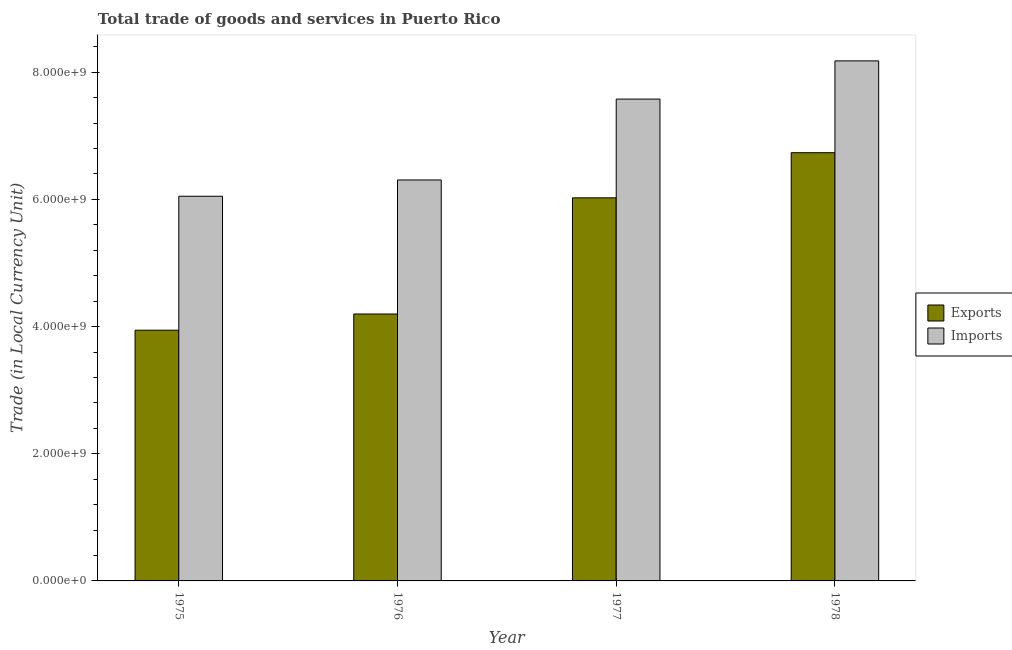How many different coloured bars are there?
Provide a succinct answer. 2. How many groups of bars are there?
Provide a succinct answer. 4. Are the number of bars per tick equal to the number of legend labels?
Keep it short and to the point. Yes. Are the number of bars on each tick of the X-axis equal?
Your answer should be very brief. Yes. How many bars are there on the 3rd tick from the left?
Ensure brevity in your answer.  2. What is the label of the 3rd group of bars from the left?
Provide a succinct answer. 1977. In how many cases, is the number of bars for a given year not equal to the number of legend labels?
Provide a succinct answer. 0. What is the imports of goods and services in 1975?
Give a very brief answer. 6.05e+09. Across all years, what is the maximum export of goods and services?
Ensure brevity in your answer.  6.74e+09. Across all years, what is the minimum imports of goods and services?
Your answer should be compact. 6.05e+09. In which year was the export of goods and services maximum?
Your answer should be very brief. 1978. In which year was the export of goods and services minimum?
Your answer should be compact. 1975. What is the total imports of goods and services in the graph?
Provide a short and direct response. 2.81e+1. What is the difference between the export of goods and services in 1977 and that in 1978?
Provide a short and direct response. -7.10e+08. What is the difference between the export of goods and services in 1975 and the imports of goods and services in 1976?
Offer a very short reply. -2.55e+08. What is the average imports of goods and services per year?
Make the answer very short. 7.03e+09. In how many years, is the export of goods and services greater than 800000000 LCU?
Provide a short and direct response. 4. What is the ratio of the export of goods and services in 1977 to that in 1978?
Provide a succinct answer. 0.89. What is the difference between the highest and the second highest imports of goods and services?
Your answer should be compact. 6.01e+08. What is the difference between the highest and the lowest imports of goods and services?
Ensure brevity in your answer.  2.13e+09. In how many years, is the imports of goods and services greater than the average imports of goods and services taken over all years?
Keep it short and to the point. 2. What does the 2nd bar from the left in 1975 represents?
Keep it short and to the point. Imports. What does the 1st bar from the right in 1976 represents?
Provide a short and direct response. Imports. Are all the bars in the graph horizontal?
Your answer should be compact. No. Does the graph contain any zero values?
Provide a succinct answer. No. Does the graph contain grids?
Make the answer very short. No. How many legend labels are there?
Your answer should be compact. 2. How are the legend labels stacked?
Give a very brief answer. Vertical. What is the title of the graph?
Provide a succinct answer. Total trade of goods and services in Puerto Rico. What is the label or title of the X-axis?
Keep it short and to the point. Year. What is the label or title of the Y-axis?
Make the answer very short. Trade (in Local Currency Unit). What is the Trade (in Local Currency Unit) in Exports in 1975?
Provide a succinct answer. 3.94e+09. What is the Trade (in Local Currency Unit) in Imports in 1975?
Your response must be concise. 6.05e+09. What is the Trade (in Local Currency Unit) in Exports in 1976?
Keep it short and to the point. 4.20e+09. What is the Trade (in Local Currency Unit) in Imports in 1976?
Offer a very short reply. 6.31e+09. What is the Trade (in Local Currency Unit) of Exports in 1977?
Provide a succinct answer. 6.02e+09. What is the Trade (in Local Currency Unit) of Imports in 1977?
Keep it short and to the point. 7.58e+09. What is the Trade (in Local Currency Unit) in Exports in 1978?
Give a very brief answer. 6.74e+09. What is the Trade (in Local Currency Unit) in Imports in 1978?
Make the answer very short. 8.18e+09. Across all years, what is the maximum Trade (in Local Currency Unit) of Exports?
Offer a terse response. 6.74e+09. Across all years, what is the maximum Trade (in Local Currency Unit) in Imports?
Provide a short and direct response. 8.18e+09. Across all years, what is the minimum Trade (in Local Currency Unit) in Exports?
Your answer should be compact. 3.94e+09. Across all years, what is the minimum Trade (in Local Currency Unit) of Imports?
Keep it short and to the point. 6.05e+09. What is the total Trade (in Local Currency Unit) in Exports in the graph?
Your answer should be compact. 2.09e+1. What is the total Trade (in Local Currency Unit) of Imports in the graph?
Ensure brevity in your answer.  2.81e+1. What is the difference between the Trade (in Local Currency Unit) of Exports in 1975 and that in 1976?
Give a very brief answer. -2.55e+08. What is the difference between the Trade (in Local Currency Unit) in Imports in 1975 and that in 1976?
Ensure brevity in your answer.  -2.56e+08. What is the difference between the Trade (in Local Currency Unit) of Exports in 1975 and that in 1977?
Provide a short and direct response. -2.08e+09. What is the difference between the Trade (in Local Currency Unit) in Imports in 1975 and that in 1977?
Keep it short and to the point. -1.53e+09. What is the difference between the Trade (in Local Currency Unit) of Exports in 1975 and that in 1978?
Your response must be concise. -2.79e+09. What is the difference between the Trade (in Local Currency Unit) of Imports in 1975 and that in 1978?
Give a very brief answer. -2.13e+09. What is the difference between the Trade (in Local Currency Unit) of Exports in 1976 and that in 1977?
Make the answer very short. -1.83e+09. What is the difference between the Trade (in Local Currency Unit) in Imports in 1976 and that in 1977?
Offer a very short reply. -1.27e+09. What is the difference between the Trade (in Local Currency Unit) in Exports in 1976 and that in 1978?
Give a very brief answer. -2.54e+09. What is the difference between the Trade (in Local Currency Unit) in Imports in 1976 and that in 1978?
Your answer should be compact. -1.87e+09. What is the difference between the Trade (in Local Currency Unit) in Exports in 1977 and that in 1978?
Your answer should be very brief. -7.10e+08. What is the difference between the Trade (in Local Currency Unit) in Imports in 1977 and that in 1978?
Give a very brief answer. -6.01e+08. What is the difference between the Trade (in Local Currency Unit) in Exports in 1975 and the Trade (in Local Currency Unit) in Imports in 1976?
Your answer should be compact. -2.36e+09. What is the difference between the Trade (in Local Currency Unit) of Exports in 1975 and the Trade (in Local Currency Unit) of Imports in 1977?
Give a very brief answer. -3.64e+09. What is the difference between the Trade (in Local Currency Unit) in Exports in 1975 and the Trade (in Local Currency Unit) in Imports in 1978?
Your answer should be very brief. -4.24e+09. What is the difference between the Trade (in Local Currency Unit) in Exports in 1976 and the Trade (in Local Currency Unit) in Imports in 1977?
Your answer should be compact. -3.38e+09. What is the difference between the Trade (in Local Currency Unit) in Exports in 1976 and the Trade (in Local Currency Unit) in Imports in 1978?
Provide a succinct answer. -3.98e+09. What is the difference between the Trade (in Local Currency Unit) of Exports in 1977 and the Trade (in Local Currency Unit) of Imports in 1978?
Your answer should be compact. -2.15e+09. What is the average Trade (in Local Currency Unit) of Exports per year?
Your response must be concise. 5.23e+09. What is the average Trade (in Local Currency Unit) of Imports per year?
Ensure brevity in your answer.  7.03e+09. In the year 1975, what is the difference between the Trade (in Local Currency Unit) of Exports and Trade (in Local Currency Unit) of Imports?
Your answer should be very brief. -2.11e+09. In the year 1976, what is the difference between the Trade (in Local Currency Unit) in Exports and Trade (in Local Currency Unit) in Imports?
Keep it short and to the point. -2.11e+09. In the year 1977, what is the difference between the Trade (in Local Currency Unit) in Exports and Trade (in Local Currency Unit) in Imports?
Make the answer very short. -1.55e+09. In the year 1978, what is the difference between the Trade (in Local Currency Unit) of Exports and Trade (in Local Currency Unit) of Imports?
Make the answer very short. -1.44e+09. What is the ratio of the Trade (in Local Currency Unit) in Exports in 1975 to that in 1976?
Your answer should be compact. 0.94. What is the ratio of the Trade (in Local Currency Unit) in Imports in 1975 to that in 1976?
Make the answer very short. 0.96. What is the ratio of the Trade (in Local Currency Unit) in Exports in 1975 to that in 1977?
Offer a terse response. 0.65. What is the ratio of the Trade (in Local Currency Unit) in Imports in 1975 to that in 1977?
Give a very brief answer. 0.8. What is the ratio of the Trade (in Local Currency Unit) in Exports in 1975 to that in 1978?
Keep it short and to the point. 0.59. What is the ratio of the Trade (in Local Currency Unit) of Imports in 1975 to that in 1978?
Provide a short and direct response. 0.74. What is the ratio of the Trade (in Local Currency Unit) of Exports in 1976 to that in 1977?
Offer a terse response. 0.7. What is the ratio of the Trade (in Local Currency Unit) of Imports in 1976 to that in 1977?
Your answer should be very brief. 0.83. What is the ratio of the Trade (in Local Currency Unit) of Exports in 1976 to that in 1978?
Provide a succinct answer. 0.62. What is the ratio of the Trade (in Local Currency Unit) in Imports in 1976 to that in 1978?
Offer a very short reply. 0.77. What is the ratio of the Trade (in Local Currency Unit) in Exports in 1977 to that in 1978?
Ensure brevity in your answer.  0.89. What is the ratio of the Trade (in Local Currency Unit) of Imports in 1977 to that in 1978?
Offer a very short reply. 0.93. What is the difference between the highest and the second highest Trade (in Local Currency Unit) of Exports?
Give a very brief answer. 7.10e+08. What is the difference between the highest and the second highest Trade (in Local Currency Unit) in Imports?
Your answer should be very brief. 6.01e+08. What is the difference between the highest and the lowest Trade (in Local Currency Unit) in Exports?
Provide a short and direct response. 2.79e+09. What is the difference between the highest and the lowest Trade (in Local Currency Unit) of Imports?
Provide a short and direct response. 2.13e+09. 